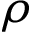Convert formula to latex. <formula><loc_0><loc_0><loc_500><loc_500>\rho</formula> 